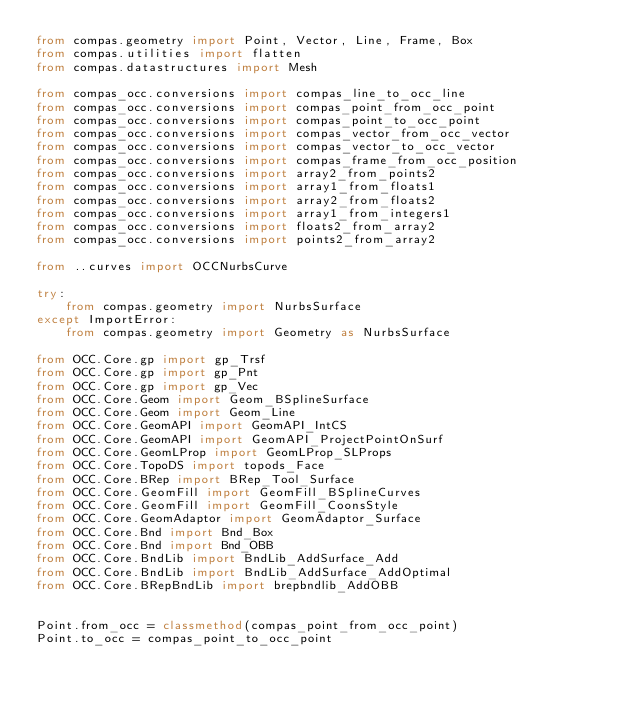Convert code to text. <code><loc_0><loc_0><loc_500><loc_500><_Python_>from compas.geometry import Point, Vector, Line, Frame, Box
from compas.utilities import flatten
from compas.datastructures import Mesh

from compas_occ.conversions import compas_line_to_occ_line
from compas_occ.conversions import compas_point_from_occ_point
from compas_occ.conversions import compas_point_to_occ_point
from compas_occ.conversions import compas_vector_from_occ_vector
from compas_occ.conversions import compas_vector_to_occ_vector
from compas_occ.conversions import compas_frame_from_occ_position
from compas_occ.conversions import array2_from_points2
from compas_occ.conversions import array1_from_floats1
from compas_occ.conversions import array2_from_floats2
from compas_occ.conversions import array1_from_integers1
from compas_occ.conversions import floats2_from_array2
from compas_occ.conversions import points2_from_array2

from ..curves import OCCNurbsCurve

try:
    from compas.geometry import NurbsSurface
except ImportError:
    from compas.geometry import Geometry as NurbsSurface

from OCC.Core.gp import gp_Trsf
from OCC.Core.gp import gp_Pnt
from OCC.Core.gp import gp_Vec
from OCC.Core.Geom import Geom_BSplineSurface
from OCC.Core.Geom import Geom_Line
from OCC.Core.GeomAPI import GeomAPI_IntCS
from OCC.Core.GeomAPI import GeomAPI_ProjectPointOnSurf
from OCC.Core.GeomLProp import GeomLProp_SLProps
from OCC.Core.TopoDS import topods_Face
from OCC.Core.BRep import BRep_Tool_Surface
from OCC.Core.GeomFill import GeomFill_BSplineCurves
from OCC.Core.GeomFill import GeomFill_CoonsStyle
from OCC.Core.GeomAdaptor import GeomAdaptor_Surface
from OCC.Core.Bnd import Bnd_Box
from OCC.Core.Bnd import Bnd_OBB
from OCC.Core.BndLib import BndLib_AddSurface_Add
from OCC.Core.BndLib import BndLib_AddSurface_AddOptimal
from OCC.Core.BRepBndLib import brepbndlib_AddOBB


Point.from_occ = classmethod(compas_point_from_occ_point)
Point.to_occ = compas_point_to_occ_point</code> 